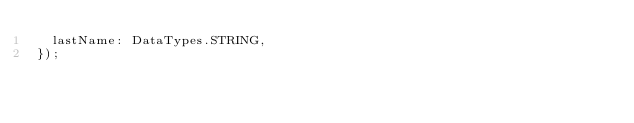<code> <loc_0><loc_0><loc_500><loc_500><_JavaScript_>  lastName: DataTypes.STRING,
});
</code> 